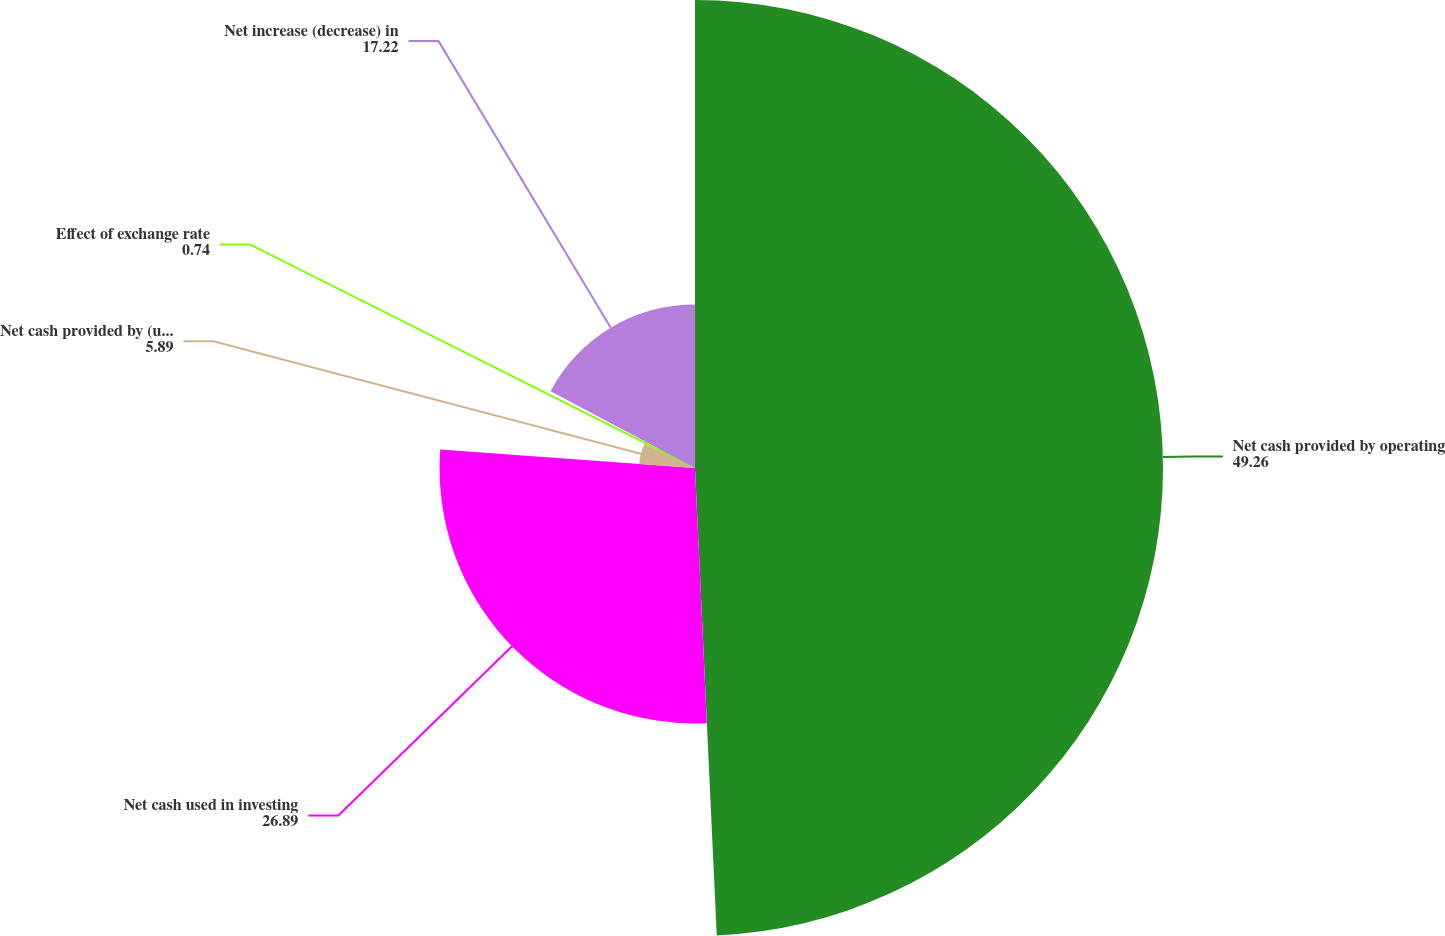Convert chart to OTSL. <chart><loc_0><loc_0><loc_500><loc_500><pie_chart><fcel>Net cash provided by operating<fcel>Net cash used in investing<fcel>Net cash provided by (used in)<fcel>Effect of exchange rate<fcel>Net increase (decrease) in<nl><fcel>49.26%<fcel>26.89%<fcel>5.89%<fcel>0.74%<fcel>17.22%<nl></chart> 